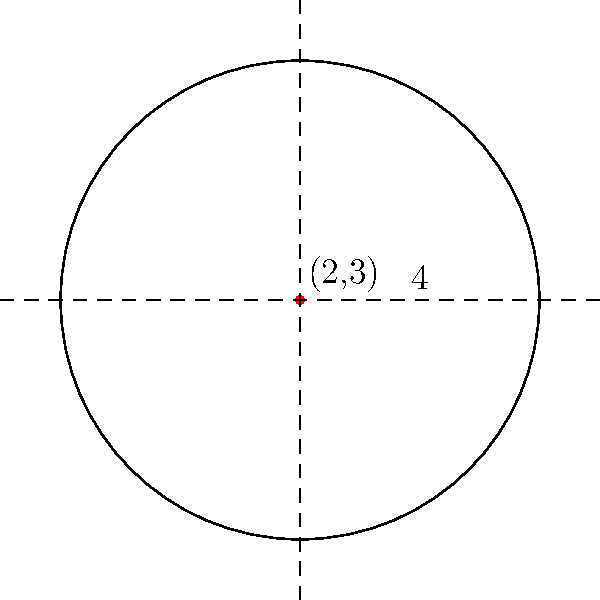In the design of a circular stained glass window for the church, you are given the equation $(x-2)^2 + (y-3)^2 = 16$. Determine the center and radius of this window, relating its circular shape to the perfection of God's creation. To find the center and radius of the circular stained glass window, we need to analyze the given equation:

$(x-2)^2 + (y-3)^2 = 16$

1. Recognize the standard form of a circle equation:
   $(x-h)^2 + (y-k)^2 = r^2$
   where $(h,k)$ is the center and $r$ is the radius.

2. Compare our equation to the standard form:
   $(x-2)^2 + (y-3)^2 = 16$
   
   We can see that:
   $h = 2$
   $k = 3$
   $r^2 = 16$

3. The center is the point $(h,k)$, so the center is $(2,3)$.

4. To find the radius, we need to take the square root of $r^2$:
   $r = \sqrt{16} = 4$

Thus, the center of the circular stained glass window is at (2,3), and its radius is 4 units.

This perfect circular shape, centered at (2,3) with a radius of 4, can be seen as a reflection of God's perfect design in creation, reminding us of the divine harmony and order in the universe.
Answer: Center: (2,3), Radius: 4 